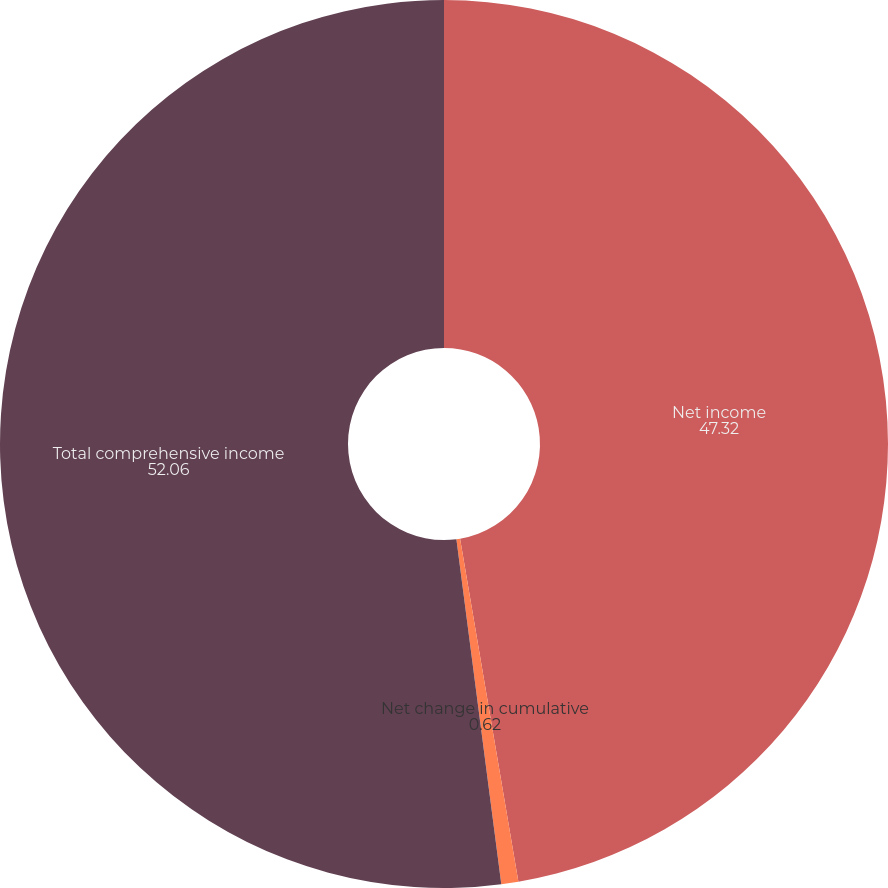<chart> <loc_0><loc_0><loc_500><loc_500><pie_chart><fcel>Net income<fcel>Net change in cumulative<fcel>Total comprehensive income<nl><fcel>47.32%<fcel>0.62%<fcel>52.06%<nl></chart> 